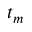<formula> <loc_0><loc_0><loc_500><loc_500>t _ { m }</formula> 